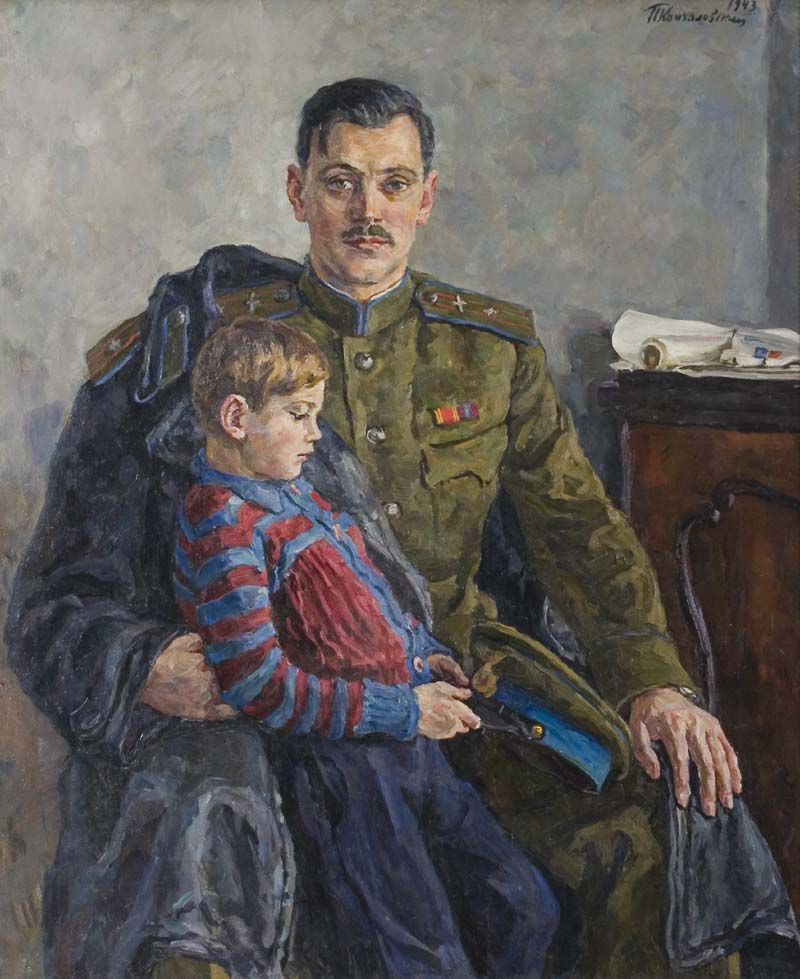How would you describe the emotions depicted in this painting? The painting invokes a mix of tenderness and solemnity. The man, dressed in a formal military uniform, carries a dignified yet pensive expression, indicating the weight of his responsibilities. The young boy, nestled in his lap, appears calm and secure, suggesting a moment of comfort and bonding between father and son. The composition captures a poignant moment of familial connection amidst the backdrop of duty and service, reflecting warmth and love juxtaposed with the serious undertones of a soldier's life. 